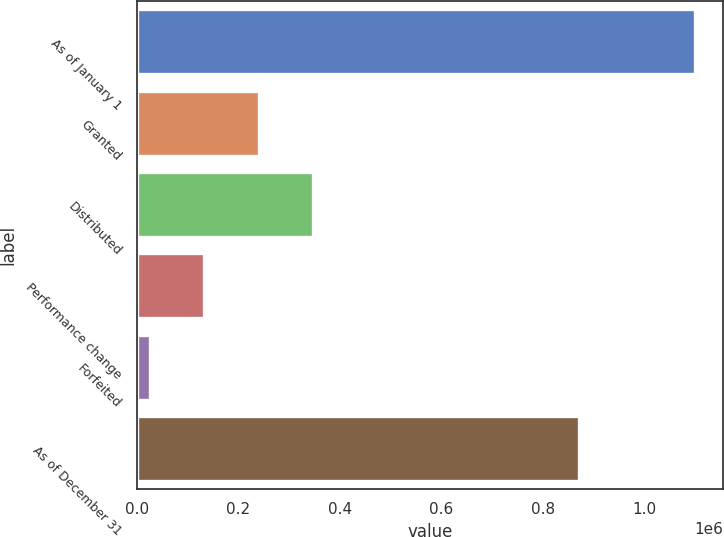Convert chart to OTSL. <chart><loc_0><loc_0><loc_500><loc_500><bar_chart><fcel>As of January 1<fcel>Granted<fcel>Distributed<fcel>Performance change<fcel>Forfeited<fcel>As of December 31<nl><fcel>1.09975e+06<fcel>240478<fcel>347888<fcel>133069<fcel>25660<fcel>871192<nl></chart> 